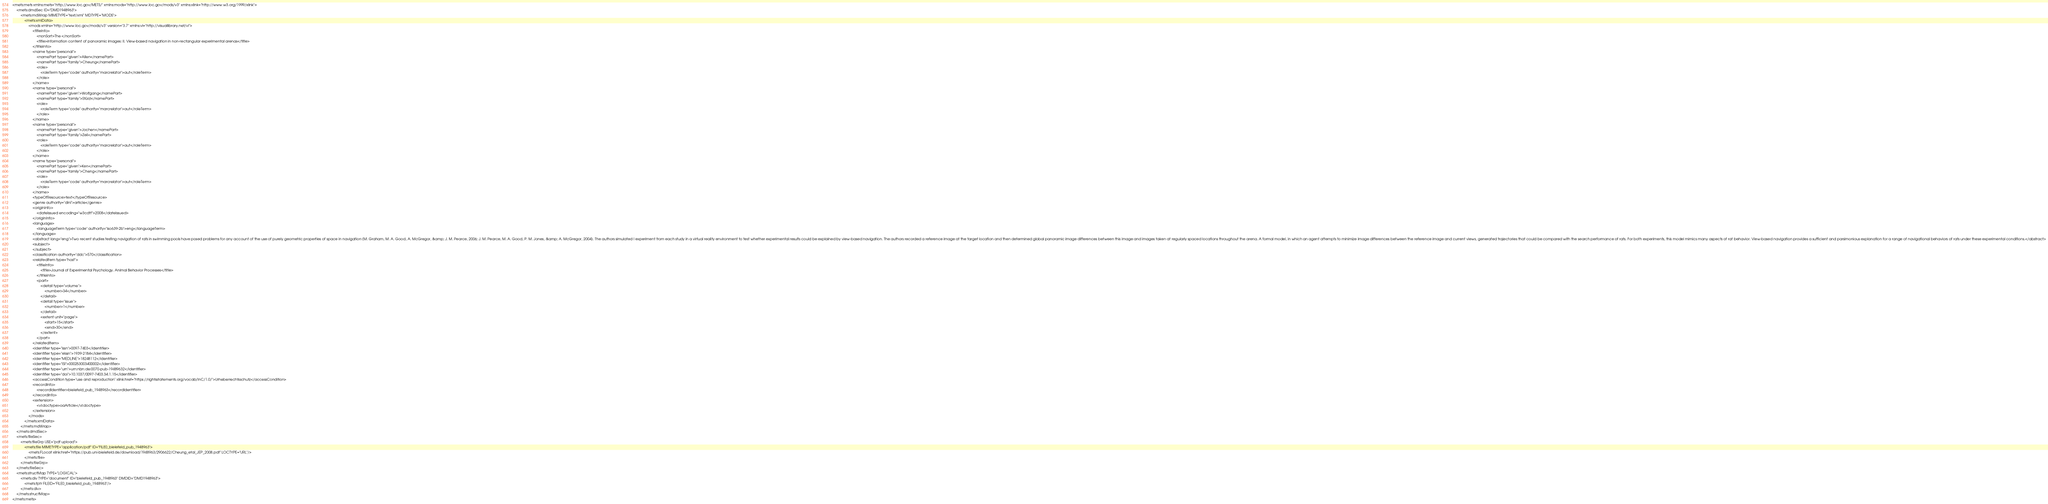<code> <loc_0><loc_0><loc_500><loc_500><_XML_><mets:mets xmlns:mets="http://www.loc.gov/METS/" xmlns:mods="http://www.loc.gov/mods/v3" xmlns:xlink="http://www.w3.org/1999/xlink">
    <mets:dmdSec ID="DMD1948963">
        <mets:mdWrap MIMETYPE="text/xml" MDTYPE="MODS">
            <mets:xmlData>
                <mods xmlns="http://www.loc.gov/mods/v3" version="3.7" xmlns:vl="http://visuallibrary.net/vl">
                    <titleInfo>
                        <nonSort>The </nonSort>
                        <title>information content of panoramic images: II. View-based navigation in non-rectangular experimental arenas</title>
                    </titleInfo>
                    <name type="personal">
                        <namePart type="given">Allen</namePart>
                        <namePart type="family">Cheung</namePart>
                        <role>
                            <roleTerm type="code" authority="marcrelator">aut</roleTerm>
                        </role>
                    </name>
                    <name type="personal">
                        <namePart type="given">Wolfgang</namePart>
                        <namePart type="family">Stürzl</namePart>
                        <role>
                            <roleTerm type="code" authority="marcrelator">aut</roleTerm>
                        </role>
                    </name>
                    <name type="personal">
                        <namePart type="given">Jochen</namePart>
                        <namePart type="family">Zeil</namePart>
                        <role>
                            <roleTerm type="code" authority="marcrelator">aut</roleTerm>
                        </role>
                    </name>
                    <name type="personal">
                        <namePart type="given">Ken</namePart>
                        <namePart type="family">Cheng</namePart>
                        <role>
                            <roleTerm type="code" authority="marcrelator">aut</roleTerm>
                        </role>
                    </name>
                    <typeOfResource>text</typeOfResource>
                    <genre authority="dini">article</genre>
                    <originInfo>
                        <dateIssued encoding="w3cdtf">2008</dateIssued>
                    </originInfo>
                    <language>
                        <languageTerm type="code" authority="iso639-2b">eng</languageTerm>
                    </language>
                    <abstract lang="eng">Two recent studies testing navigation of rats in swimming pools have posed problems for any account of the use of purely geometric properties of space in navigation (M. Graham, M. A. Good, A. McGregor, &amp; J. M. Pearce, 2006; J. M. Pearce, M. A. Good, P. M. Jones, &amp; A. McGregor, 2004). The authors simulated I experiment from each study in a virtual reality environment to test whether experimental results could be explained by view-based navigation. The authors recorded a reference image at the target location and then determined global panoramic image differences between this image and images taken at regularly spaced locations throughout the arena. A formal model, in which an agent attempts to minimize image differences between the reference image and current views, generated trajectories that could be compared with the search performance of rats. For both experiments, this model mimics many aspects of rat behavior. View-based navigation provides a sufficient and parsimonious explanation for a range of navigational behaviors of rats under these experimental conditions.</abstract>
                    <subject>
                    </subject>
                    <classification authority="ddc">570</classification>
                    <relatedItem type="host">
                        <titleInfo>
                            <title>Journal of Experimental Psychology. Animal Behavior Processes</title>
                        </titleInfo>
                        <part>
                            <detail type="volume">
                                <number>34</number>
                            </detail>
                            <detail type="issue">
                                <number>1</number>
                            </detail>
                            <extent unit="page">
                                <start>15</start>
                                <end>30</end>
                            </extent>
                        </part>
                    </relatedItem>
                    <identifier type="issn">0097-7403</identifier>
                    <identifier type="eIssn">1939-2184</identifier>
                    <identifier type="MEDLINE">18248112</identifier>
                    <identifier type="ISI">000253003400002</identifier>
                    <identifier type="urn">urn:nbn:de:0070-pub-19489632</identifier>
                    <identifier type="doi">10.1037/0097-7403.34.1.15</identifier>
                    <accessCondition type="use and reproduction" xlink:href="https://rightsstatements.org/vocab/InC/1.0/">Urheberrechtsschutz</accessCondition>
                    <recordInfo>
                        <recordIdentifier>bielefeld_pub_1948963</recordIdentifier>
                    </recordInfo>
                    <extension>
                        <vl:doctype>oaArticle</vl:doctype>
                    </extension>
                </mods>
            </mets:xmlData>
        </mets:mdWrap>
    </mets:dmdSec>
    <mets:fileSec>
        <mets:fileGrp USE="pdf upload">
            <mets:file MIMETYPE="application/pdf" ID="FILE0_bielefeld_pub_1948963">
                <mets:FLocat xlink:href="https://pub.uni-bielefeld.de/download/1948963/2906622/Cheung_etal_JEP_2008.pdf" LOCTYPE="URL"/>
            </mets:file>
        </mets:fileGrp>
    </mets:fileSec>
    <mets:structMap TYPE="LOGICAL">
        <mets:div TYPE="document" ID="bielefeld_pub_1948963" DMDID="DMD1948963">
            <mets:fptr FILEID="FILE0_bielefeld_pub_1948963"/>
        </mets:div>
    </mets:structMap>
</mets:mets>
</code> 